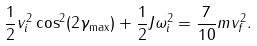Convert formula to latex. <formula><loc_0><loc_0><loc_500><loc_500>\frac { 1 } { 2 } v _ { i } ^ { 2 } \cos ^ { 2 } ( 2 \gamma _ { \max } ) + \frac { 1 } { 2 } J \omega _ { i } ^ { 2 } = \frac { 7 } { 1 0 } m v _ { f } ^ { 2 } .</formula> 